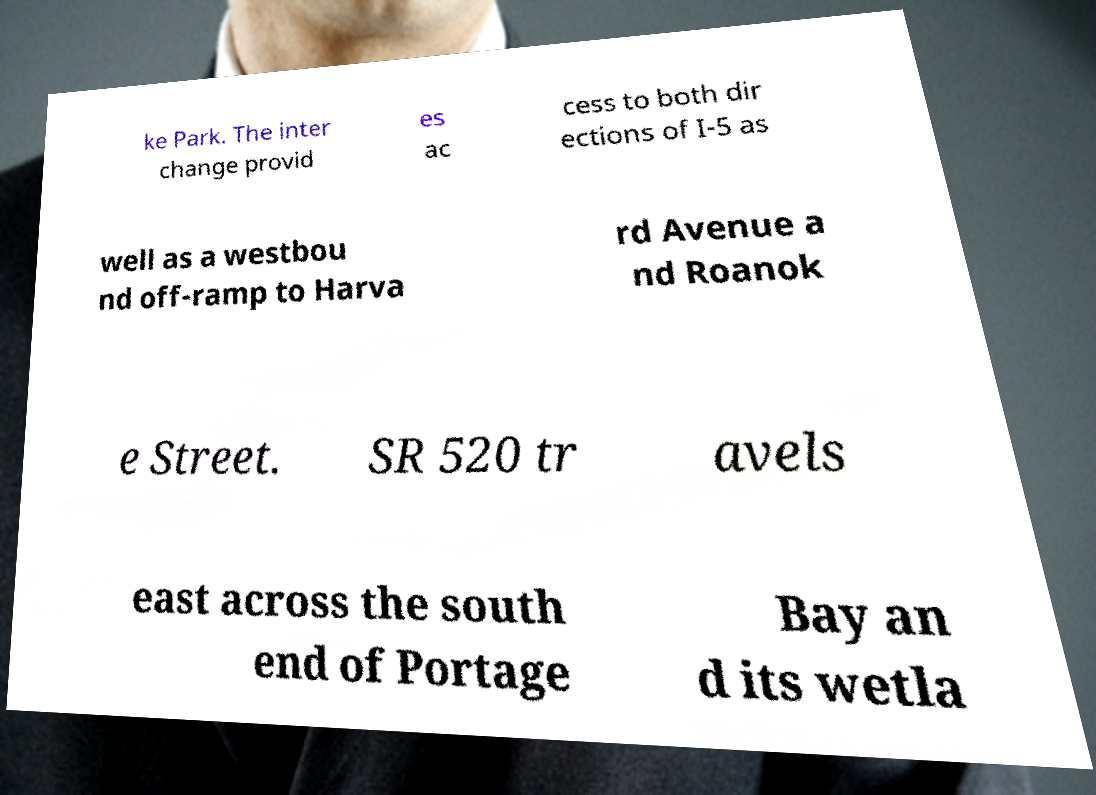There's text embedded in this image that I need extracted. Can you transcribe it verbatim? ke Park. The inter change provid es ac cess to both dir ections of I-5 as well as a westbou nd off-ramp to Harva rd Avenue a nd Roanok e Street. SR 520 tr avels east across the south end of Portage Bay an d its wetla 